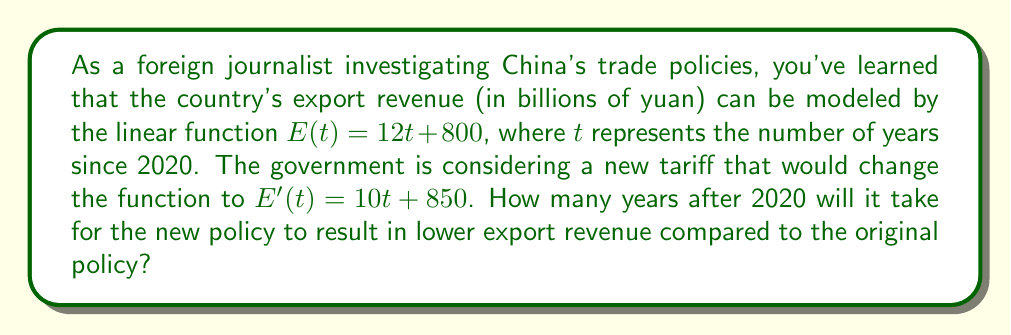Could you help me with this problem? Let's approach this step-by-step:

1) We have two linear functions:
   Original policy: $E(t) = 12t + 800$
   New policy: $E'(t) = 10t + 850$

2) We need to find the point where these functions intersect. At this point, the export revenues will be equal.

3) Set the functions equal to each other:
   $12t + 800 = 10t + 850$

4) Solve for $t$:
   $12t - 10t = 850 - 800$
   $2t = 50$
   $t = 25$

5) This means that 25 years after 2020, the export revenues will be equal under both policies.

6) To determine when the new policy results in lower revenue, we need to consider what happens after this point.

7) The slope of $E(t)$ is 12, while the slope of $E'(t)$ is 10. This means that after the intersection point, $E(t)$ will be greater than $E'(t)$.

8) Therefore, immediately after 25 years, the new policy will result in lower export revenue.
Answer: 26 years 